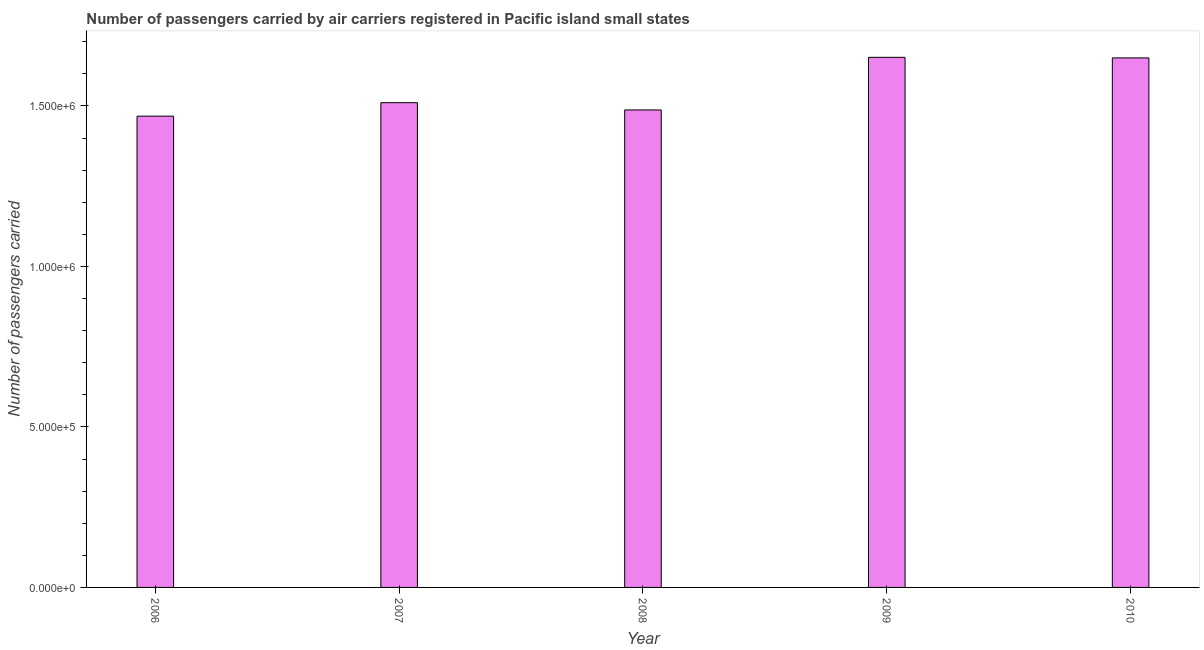What is the title of the graph?
Keep it short and to the point. Number of passengers carried by air carriers registered in Pacific island small states. What is the label or title of the Y-axis?
Your response must be concise. Number of passengers carried. What is the number of passengers carried in 2007?
Your answer should be compact. 1.51e+06. Across all years, what is the maximum number of passengers carried?
Ensure brevity in your answer.  1.65e+06. Across all years, what is the minimum number of passengers carried?
Your answer should be very brief. 1.47e+06. In which year was the number of passengers carried maximum?
Your response must be concise. 2009. In which year was the number of passengers carried minimum?
Your answer should be very brief. 2006. What is the sum of the number of passengers carried?
Your response must be concise. 7.77e+06. What is the difference between the number of passengers carried in 2008 and 2009?
Provide a succinct answer. -1.64e+05. What is the average number of passengers carried per year?
Offer a terse response. 1.55e+06. What is the median number of passengers carried?
Provide a succinct answer. 1.51e+06. What is the ratio of the number of passengers carried in 2007 to that in 2009?
Offer a terse response. 0.91. Is the number of passengers carried in 2006 less than that in 2010?
Offer a terse response. Yes. What is the difference between the highest and the second highest number of passengers carried?
Provide a short and direct response. 1774. What is the difference between the highest and the lowest number of passengers carried?
Provide a succinct answer. 1.83e+05. In how many years, is the number of passengers carried greater than the average number of passengers carried taken over all years?
Keep it short and to the point. 2. How many bars are there?
Give a very brief answer. 5. Are the values on the major ticks of Y-axis written in scientific E-notation?
Offer a very short reply. Yes. What is the Number of passengers carried of 2006?
Your answer should be compact. 1.47e+06. What is the Number of passengers carried of 2007?
Your answer should be very brief. 1.51e+06. What is the Number of passengers carried in 2008?
Your answer should be very brief. 1.49e+06. What is the Number of passengers carried of 2009?
Your answer should be very brief. 1.65e+06. What is the Number of passengers carried of 2010?
Make the answer very short. 1.65e+06. What is the difference between the Number of passengers carried in 2006 and 2007?
Ensure brevity in your answer.  -4.20e+04. What is the difference between the Number of passengers carried in 2006 and 2008?
Provide a succinct answer. -1.93e+04. What is the difference between the Number of passengers carried in 2006 and 2009?
Offer a very short reply. -1.83e+05. What is the difference between the Number of passengers carried in 2006 and 2010?
Ensure brevity in your answer.  -1.81e+05. What is the difference between the Number of passengers carried in 2007 and 2008?
Your answer should be compact. 2.27e+04. What is the difference between the Number of passengers carried in 2007 and 2009?
Offer a very short reply. -1.41e+05. What is the difference between the Number of passengers carried in 2007 and 2010?
Your answer should be very brief. -1.39e+05. What is the difference between the Number of passengers carried in 2008 and 2009?
Give a very brief answer. -1.64e+05. What is the difference between the Number of passengers carried in 2008 and 2010?
Offer a very short reply. -1.62e+05. What is the difference between the Number of passengers carried in 2009 and 2010?
Provide a short and direct response. 1774. What is the ratio of the Number of passengers carried in 2006 to that in 2008?
Your answer should be compact. 0.99. What is the ratio of the Number of passengers carried in 2006 to that in 2009?
Your response must be concise. 0.89. What is the ratio of the Number of passengers carried in 2006 to that in 2010?
Offer a terse response. 0.89. What is the ratio of the Number of passengers carried in 2007 to that in 2009?
Give a very brief answer. 0.91. What is the ratio of the Number of passengers carried in 2007 to that in 2010?
Provide a short and direct response. 0.92. What is the ratio of the Number of passengers carried in 2008 to that in 2009?
Keep it short and to the point. 0.9. What is the ratio of the Number of passengers carried in 2008 to that in 2010?
Make the answer very short. 0.9. 